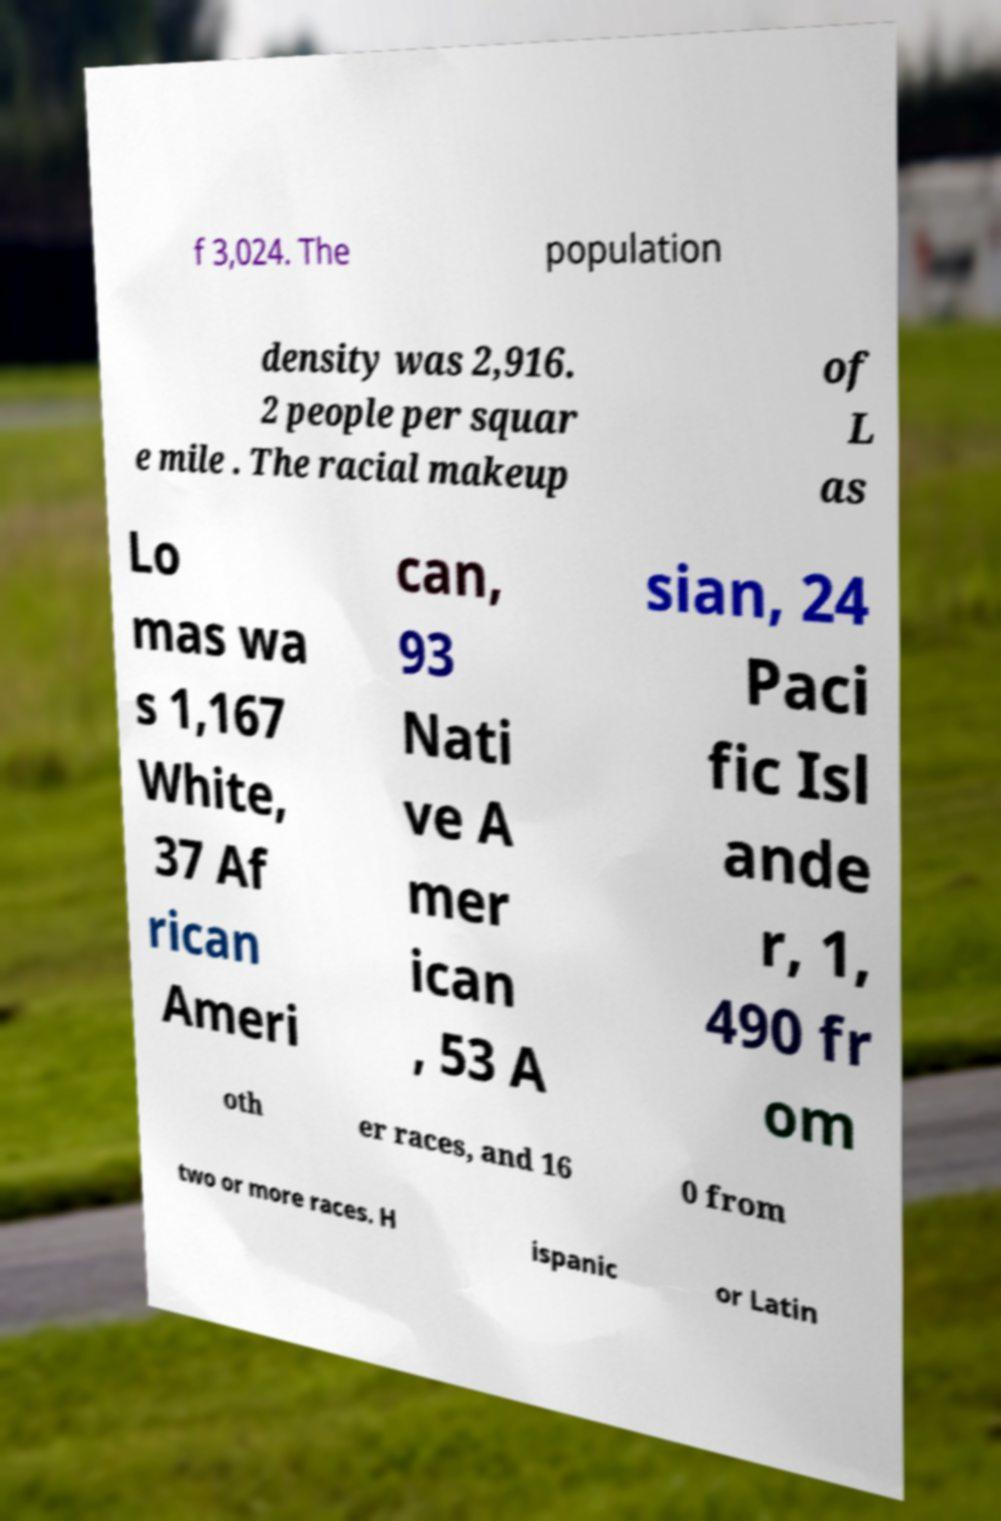Please read and relay the text visible in this image. What does it say? f 3,024. The population density was 2,916. 2 people per squar e mile . The racial makeup of L as Lo mas wa s 1,167 White, 37 Af rican Ameri can, 93 Nati ve A mer ican , 53 A sian, 24 Paci fic Isl ande r, 1, 490 fr om oth er races, and 16 0 from two or more races. H ispanic or Latin 